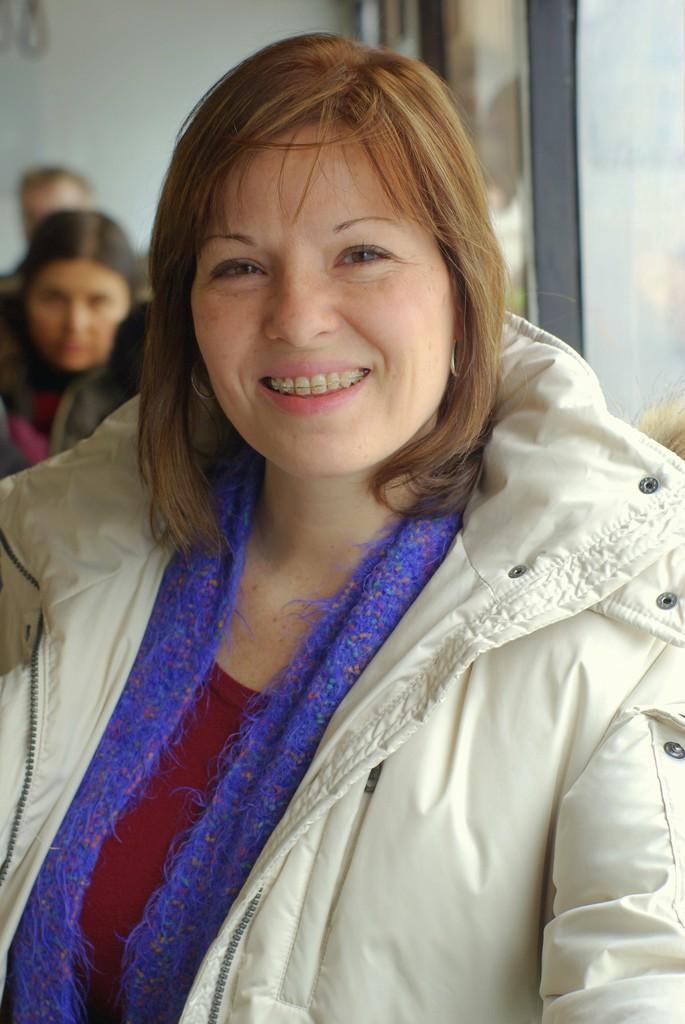How would you summarize this image in a sentence or two? In this picture we can see a woman and she is smiling and in the background we can see people, wall and the glass object. 